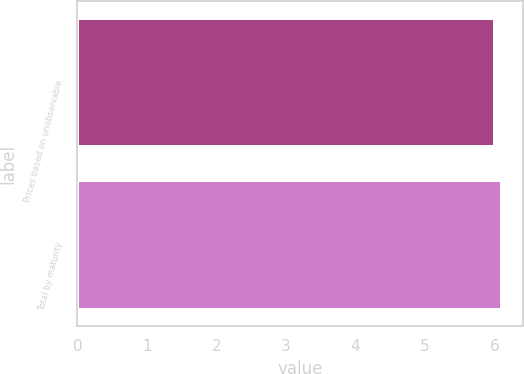Convert chart. <chart><loc_0><loc_0><loc_500><loc_500><bar_chart><fcel>Prices based on unobservable<fcel>Total by maturity<nl><fcel>6<fcel>6.1<nl></chart> 